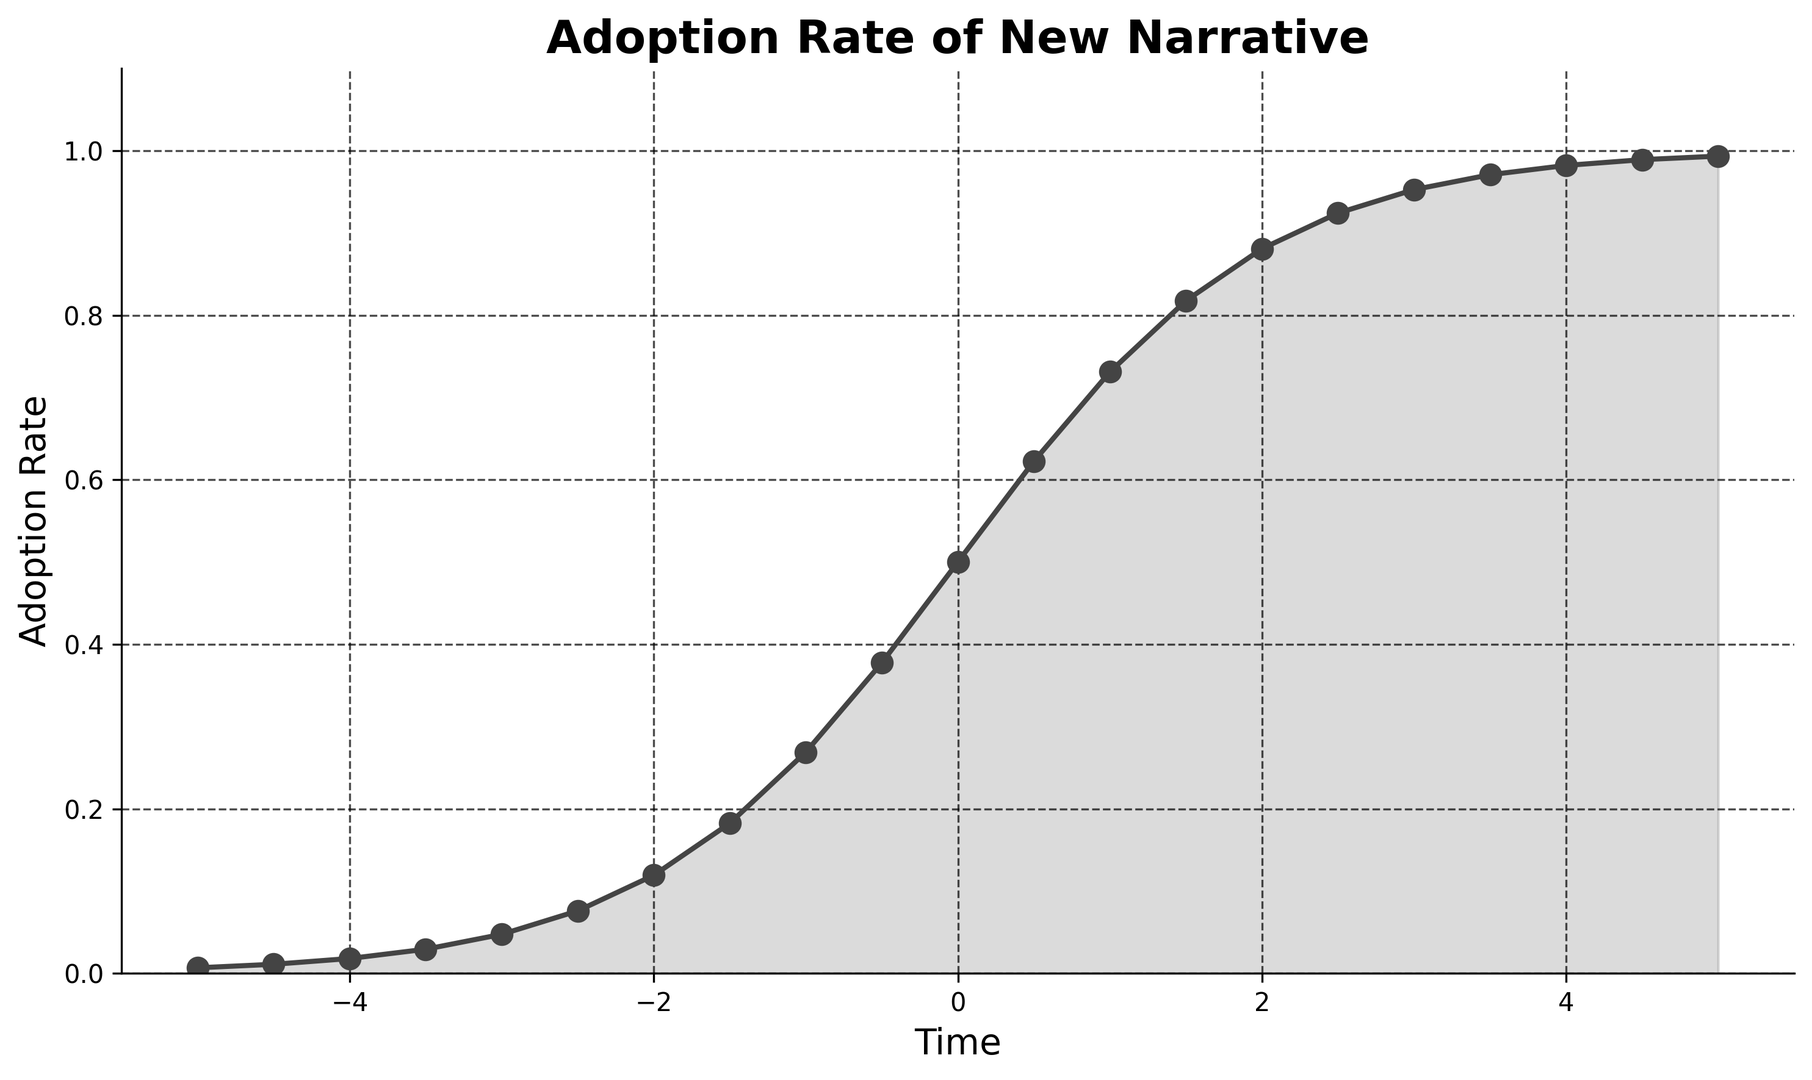What is the adoption rate at time 0? At time 0, the adoption rate corresponds to the y-value directly above x=0 on the plot. Examining the figure, we see the adoption rate is 0.5.
Answer: 0.5 How does the adoption rate change from time -2 to time 2? To find the change in adoption rate between time -2 and 2, we look at the y-values for these x-values. At time -2, it's approximately 0.119, and at time 2, it's approximately 0.881. The increase in adoption rate is 0.881 - 0.119.
Answer: 0.762 Compare the adoption rate at time -3.5 with that at time 3.5. Which is higher? The y-value at time -3.5 is 0.0293, and the y-value at time 3.5 is 0.9707. Comparing these values, the adoption rate at time 3.5 is higher.
Answer: Time 3.5 Does the adoption rate reach a value of 1 at any time within the plot's x-axis range? Observing the y-axis values throughout the plot, we see that it approaches but never reaches exactly 1 within the given x-axis range.
Answer: No What is the sum of the adoption rates at time -5 and 5? The y-value at time -5 is 0.0067, and at time 5, it's 0.9933. Adding these values gives 0.0067 + 0.9933.
Answer: 1 Is there a point in time where the adoption rate is exactly half of what it is at time 1? The adoption rate at time 1 is 0.7311. Half of this value is 0.7311 / 2 = 0.36555. The nearest value on the plot that matches this is at time -0.5, where the adoption rate is 0.3775, which is very close but not exact.
Answer: No Which time shows the steepest increase in adoption rate within the provided range? The steepest increase can be determined by visually identifying the steepest slope on the curve. The section from time -1 to 1 has a very sharp increase and is the steepest.
Answer: Time -1 to 1 At what times is the adoption rate above 0.95? Observing the plot, the adoption rate exceeds 0.95 approximately around times 2.5 and onwards up to the maximum x-value given.
Answer: 2.5 to 5 What is the average adoption rate from time -1 to 1? The adoption rates at times -1, 0, and 1 are 0.2689, 0.5, and 0.7311 respectively. The average is calculated as (0.2689 + 0.5 + 0.7311) / 3.
Answer: 0.5 